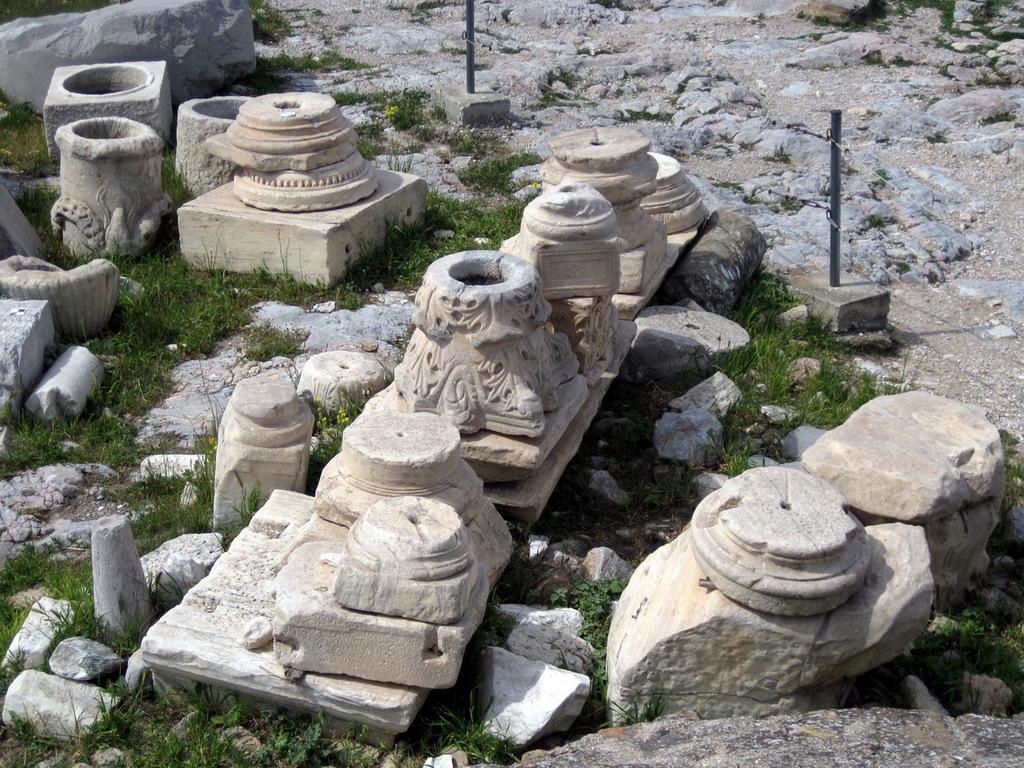Please provide a concise description of this image. In this image there are sculptures and in front of them fencing was done. 